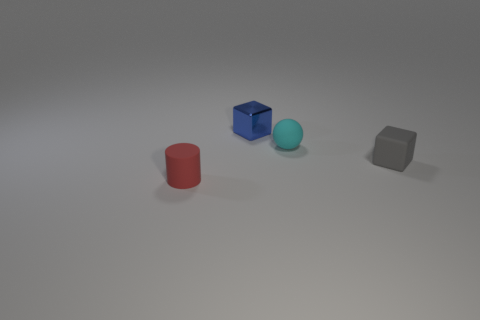Subtract all cylinders. How many objects are left? 3 Subtract all gray cubes. How many cubes are left? 1 Add 1 small cyan balls. How many objects exist? 5 Subtract all small red things. Subtract all yellow metallic spheres. How many objects are left? 3 Add 2 tiny cyan balls. How many tiny cyan balls are left? 3 Add 4 tiny red rubber things. How many tiny red rubber things exist? 5 Subtract 1 red cylinders. How many objects are left? 3 Subtract 1 cubes. How many cubes are left? 1 Subtract all cyan cubes. Subtract all cyan balls. How many cubes are left? 2 